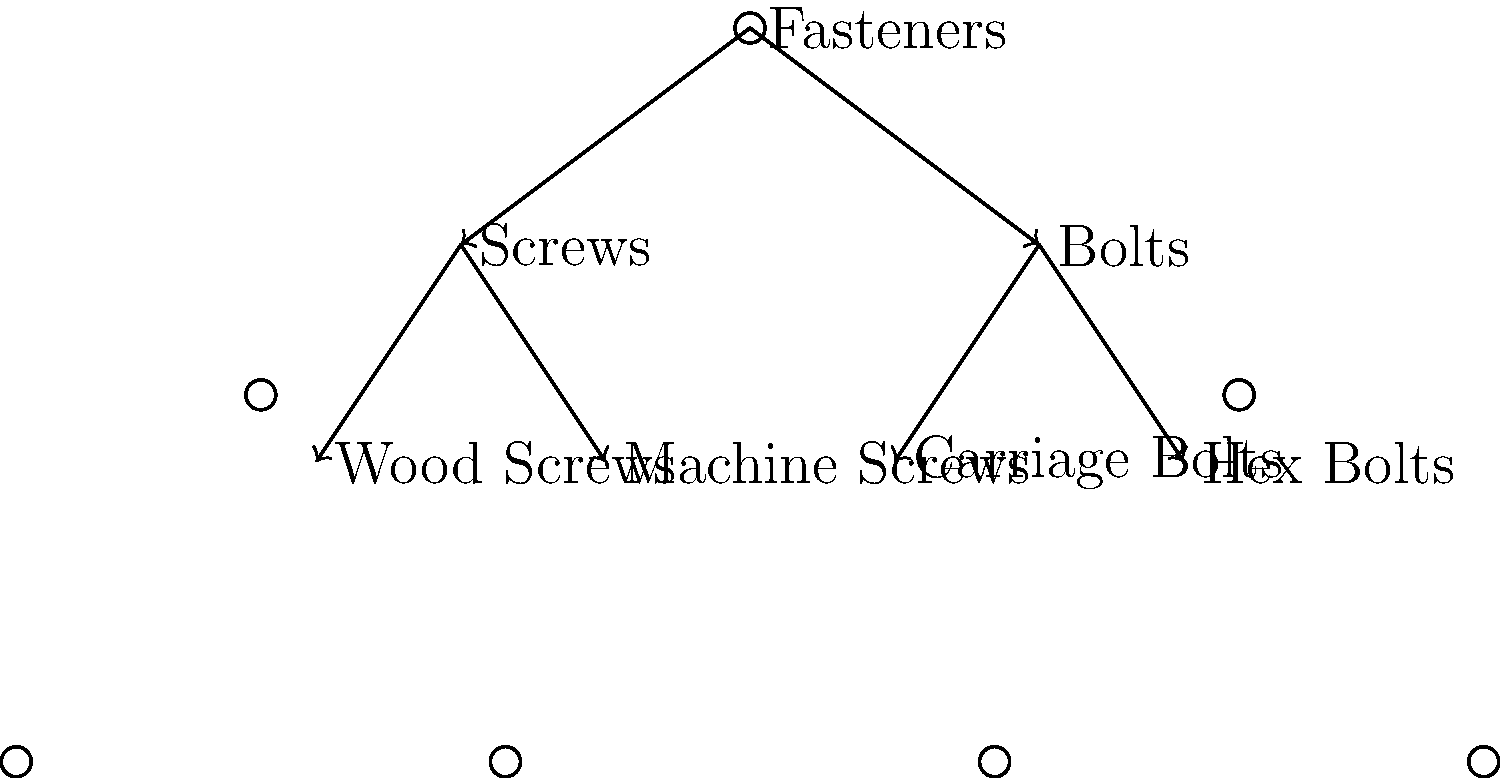Based on the hierarchical tree diagram of fasteners, which category of fasteners includes both Wood Screws and Machine Screws? To answer this question, we need to analyze the hierarchical tree diagram step by step:

1. The diagram shows "Fasteners" as the root node, representing the main category.
2. Under "Fasteners," there are two subcategories: "Screws" and "Bolts."
3. The "Screws" subcategory branches into two types: "Wood Screws" and "Machine Screws."
4. The "Bolts" subcategory branches into "Carriage Bolts" and "Hex Bolts."

Looking at the structure, we can see that both "Wood Screws" and "Machine Screws" are connected to the "Screws" node. This indicates that "Screws" is the category that includes both Wood Screws and Machine Screws.
Answer: Screws 